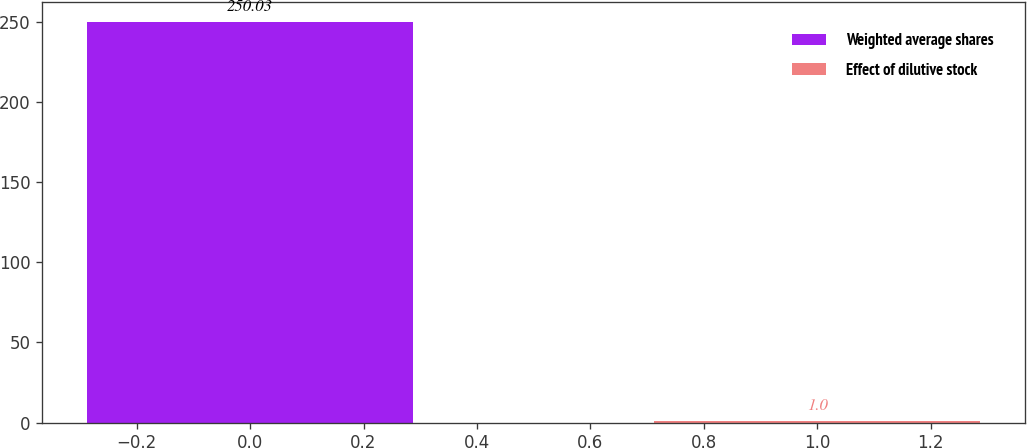<chart> <loc_0><loc_0><loc_500><loc_500><bar_chart><fcel>Weighted average shares<fcel>Effect of dilutive stock<nl><fcel>250.03<fcel>1<nl></chart> 